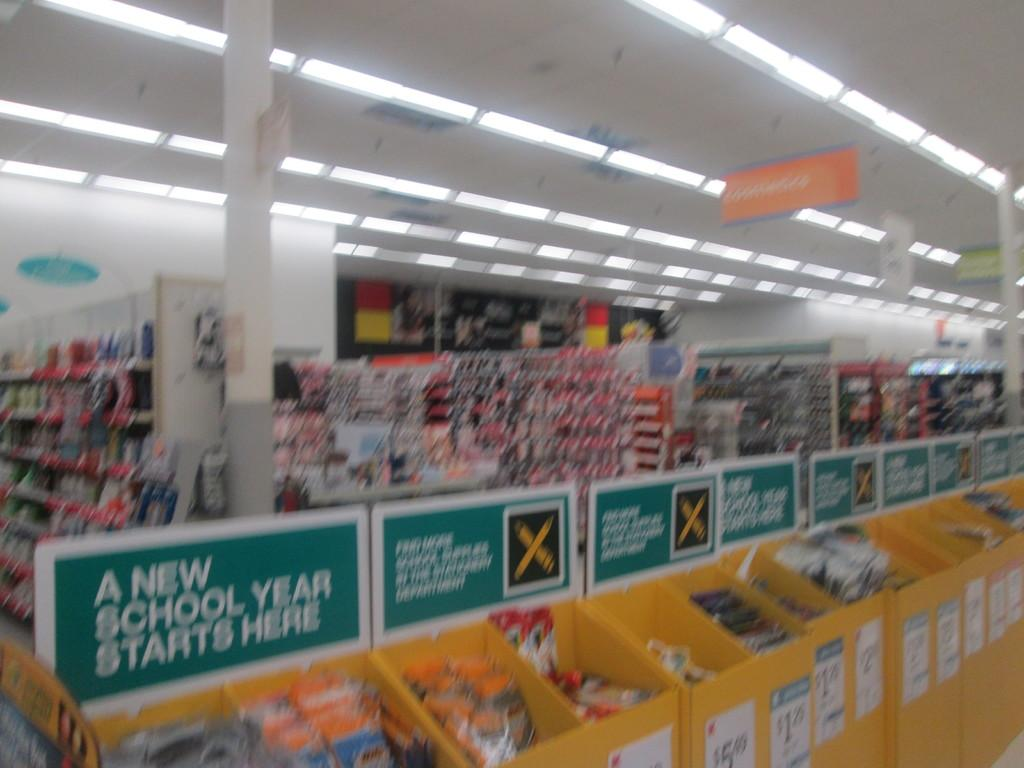<image>
Offer a succinct explanation of the picture presented. A store display has a sign which says A New School Year Starts Here. 